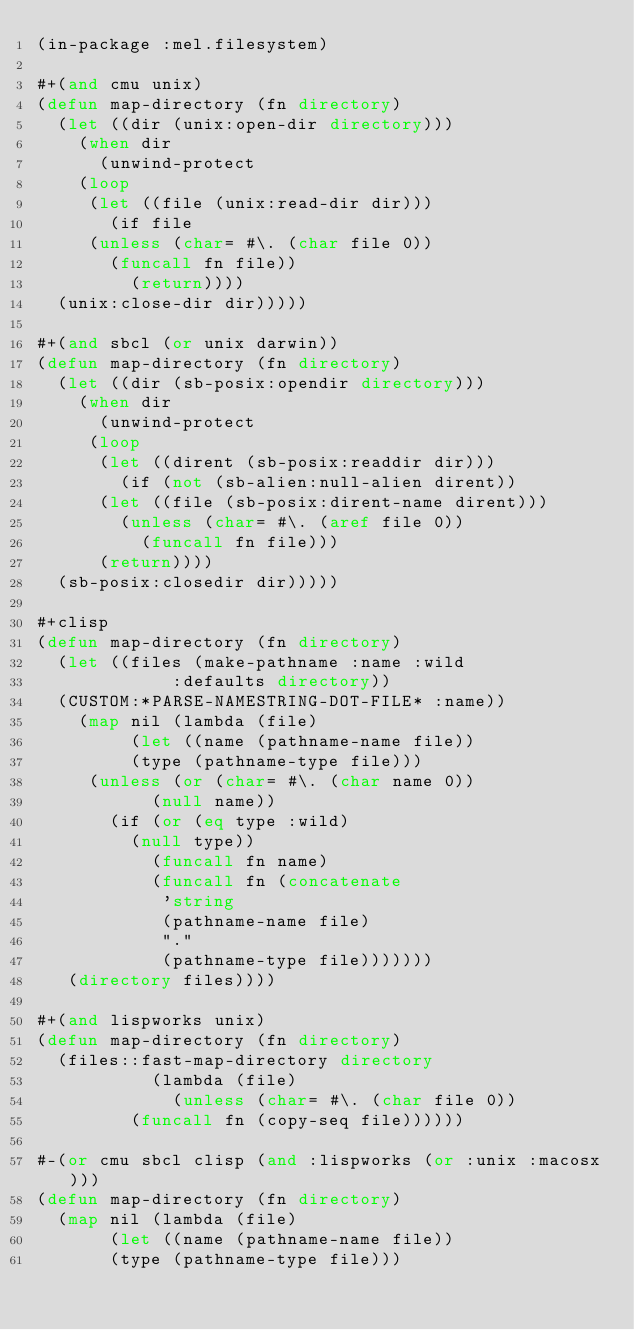<code> <loc_0><loc_0><loc_500><loc_500><_Lisp_>(in-package :mel.filesystem)

#+(and cmu unix)
(defun map-directory (fn directory)
  (let ((dir (unix:open-dir directory)))
    (when dir
      (unwind-protect
	  (loop
	   (let ((file (unix:read-dir dir)))
	     (if file
		 (unless (char= #\. (char file 0))
		   (funcall fn file))
	       (return))))
	(unix:close-dir dir)))))

#+(and sbcl (or unix darwin))
(defun map-directory (fn directory)
  (let ((dir (sb-posix:opendir directory)))
    (when dir
      (unwind-protect
	   (loop
	    (let ((dirent (sb-posix:readdir dir)))
	      (if (not (sb-alien:null-alien dirent))
		  (let ((file (sb-posix:dirent-name dirent)))
		    (unless (char= #\. (aref file 0))
		      (funcall fn file)))
		  (return))))
	(sb-posix:closedir dir)))))

#+clisp
(defun map-directory (fn directory)
  (let ((files (make-pathname :name :wild
			       :defaults directory))
	(CUSTOM:*PARSE-NAMESTRING-DOT-FILE* :name))
    (map nil (lambda (file)
	       (let ((name (pathname-name file))
		     (type (pathname-type file)))
		 (unless (or (char= #\. (char name 0))
			     (null name))
		   (if (or (eq type :wild)
			   (null type))
		       (funcall fn name)
		       (funcall fn (concatenate 
				    'string
				    (pathname-name file)
				    "."
				    (pathname-type file)))))))
	 (directory files))))

#+(and lispworks unix)
(defun map-directory (fn directory)
  (files::fast-map-directory directory 
			     (lambda (file)
			       (unless (char= #\. (char file 0))
				 (funcall fn (copy-seq file))))))

#-(or cmu sbcl clisp (and :lispworks (or :unix :macosx)))
(defun map-directory (fn directory)
  (map nil (lambda (file)
	     (let ((name (pathname-name file))
		   (type (pathname-type file)))</code> 